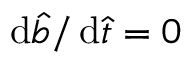Convert formula to latex. <formula><loc_0><loc_0><loc_500><loc_500>d \hat { b } / \, d \hat { t } = 0</formula> 